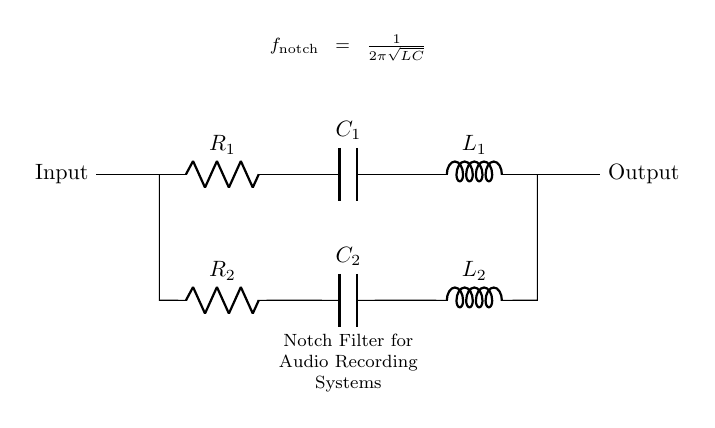What components are present in this circuit? The circuit contains a resistor, capacitor, and inductor in two parallel branches, specifically R1, C1, L1 in one branch, and R2, C2, L2 in the other.
Answer: Resistor, Capacitor, Inductor What is the function of the notch filter in this circuit? The notch filter is designed to remove specific unwanted frequencies from audio signals, allowing other frequencies to pass without significant attenuation.
Answer: Remove unwanted frequencies What is the formula for the notch frequency in this circuit? The formula is given in the diagram as f notched equals one over two pi times the square root of LC, where L and C are values from the circuit components.
Answer: f notched equals one over two pi times the square root of LC How many branches are there in the circuit? There are two branches in the circuit, one for the first set of components (R1, C1, L1) and another for the second set (R2, C2, L2).
Answer: Two What kind of filter is shown in this circuit? The circuit demonstrates a notch filter, which specifically targets and eliminates selected frequency ranges while allowing others to remain unaffected.
Answer: Notch filter 